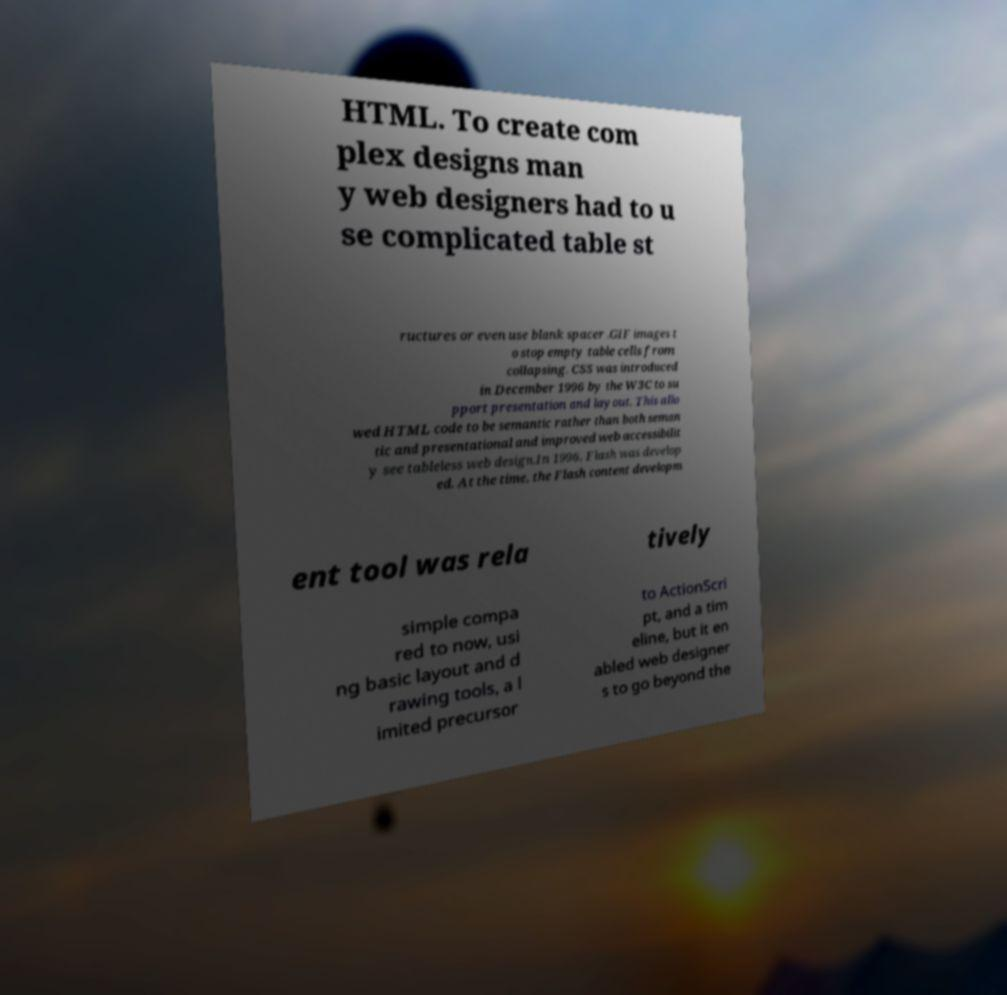What messages or text are displayed in this image? I need them in a readable, typed format. HTML. To create com plex designs man y web designers had to u se complicated table st ructures or even use blank spacer .GIF images t o stop empty table cells from collapsing. CSS was introduced in December 1996 by the W3C to su pport presentation and layout. This allo wed HTML code to be semantic rather than both seman tic and presentational and improved web accessibilit y see tableless web design.In 1996, Flash was develop ed. At the time, the Flash content developm ent tool was rela tively simple compa red to now, usi ng basic layout and d rawing tools, a l imited precursor to ActionScri pt, and a tim eline, but it en abled web designer s to go beyond the 